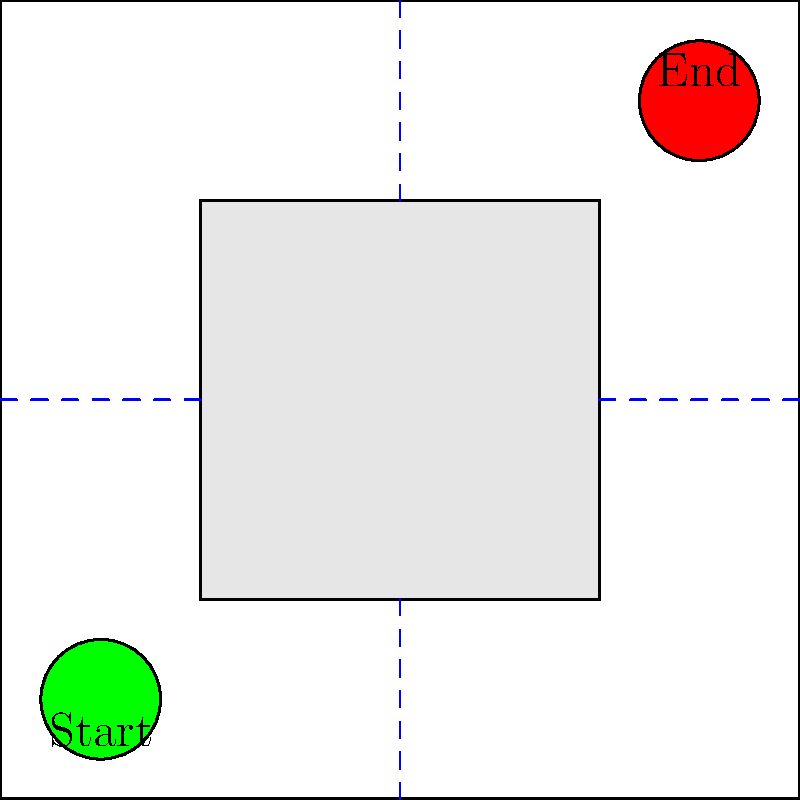In the maze above, you need to navigate from the green "Start" circle to the red "End" circle. The blue dashed lines represent congruent line segments. If the length of each side of the central gray square is 2 units, what is the total distance of the shortest path from Start to End? Let's approach this step-by-step:

1) First, we need to recognize that the shortest path will consist of two parts: from Start to a corner of the central square, and from the opposite corner of the central square to End.

2) Due to the congruence of the blue dashed lines, we know that:
   - The distance from the left edge to the central square is equal to the distance from the central square to the right edge.
   - The distance from the top edge to the central square is equal to the distance from the central square to the bottom edge.

3) Given that each side of the central square is 2 units, and the maze is a 4x4 grid, we can deduce that each blue dashed line is 1 unit long.

4) The shortest path will be:
   - 1 unit right and 1 unit up from Start to reach the bottom-left corner of the central square
   - 2 units right and 2 units up along the edge of the central square
   - 1 unit right and 1 unit up from the top-right corner of the central square to reach End

5) Adding these up:
   $$(1+1) + (2+2) + (1+1) = 2 + 4 + 2 = 8$$

Therefore, the total distance of the shortest path is 8 units.
Answer: 8 units 